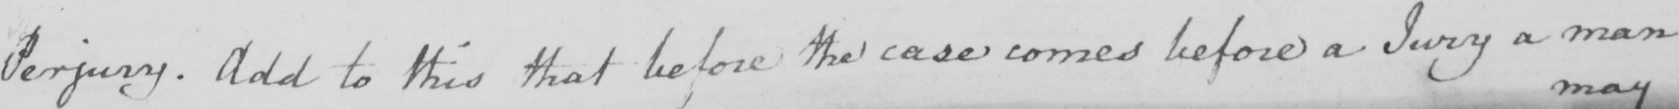Can you read and transcribe this handwriting? Perjury . Add to this that before the case comes before a Jury a man 